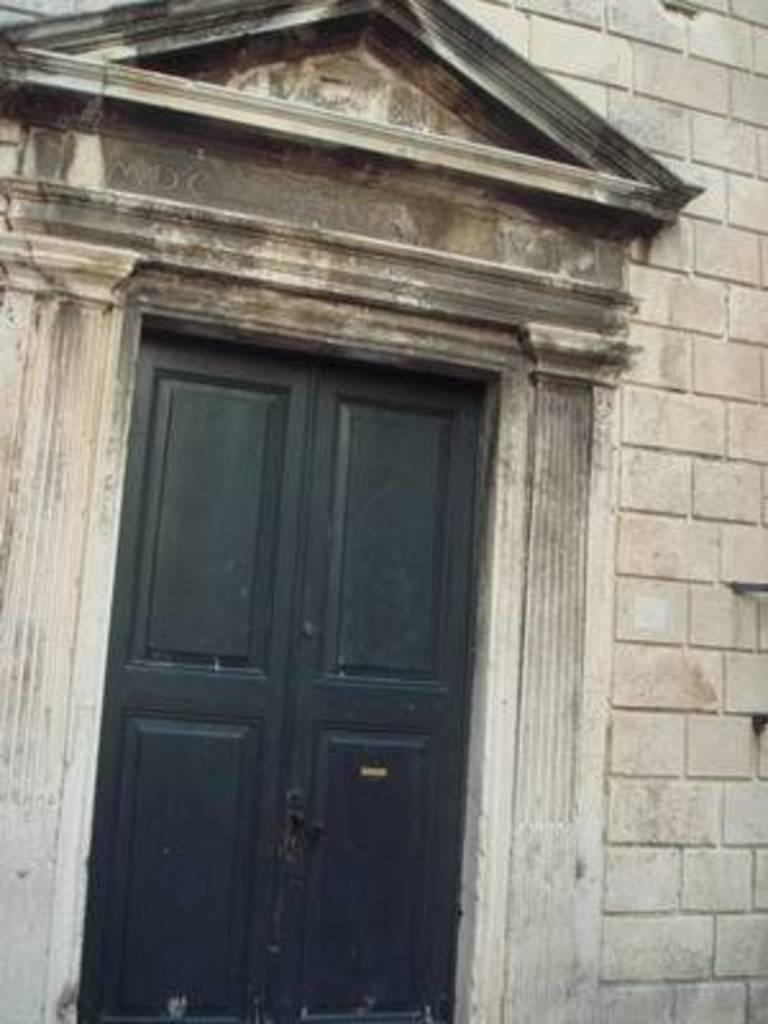What is the main architectural feature in the image? There is a door in the image. What other structural element can be seen on the right side of the image? There is a wall on the right side of the image. How many eyes can be seen on the door in the image? There are no eyes visible on the door in the image. 